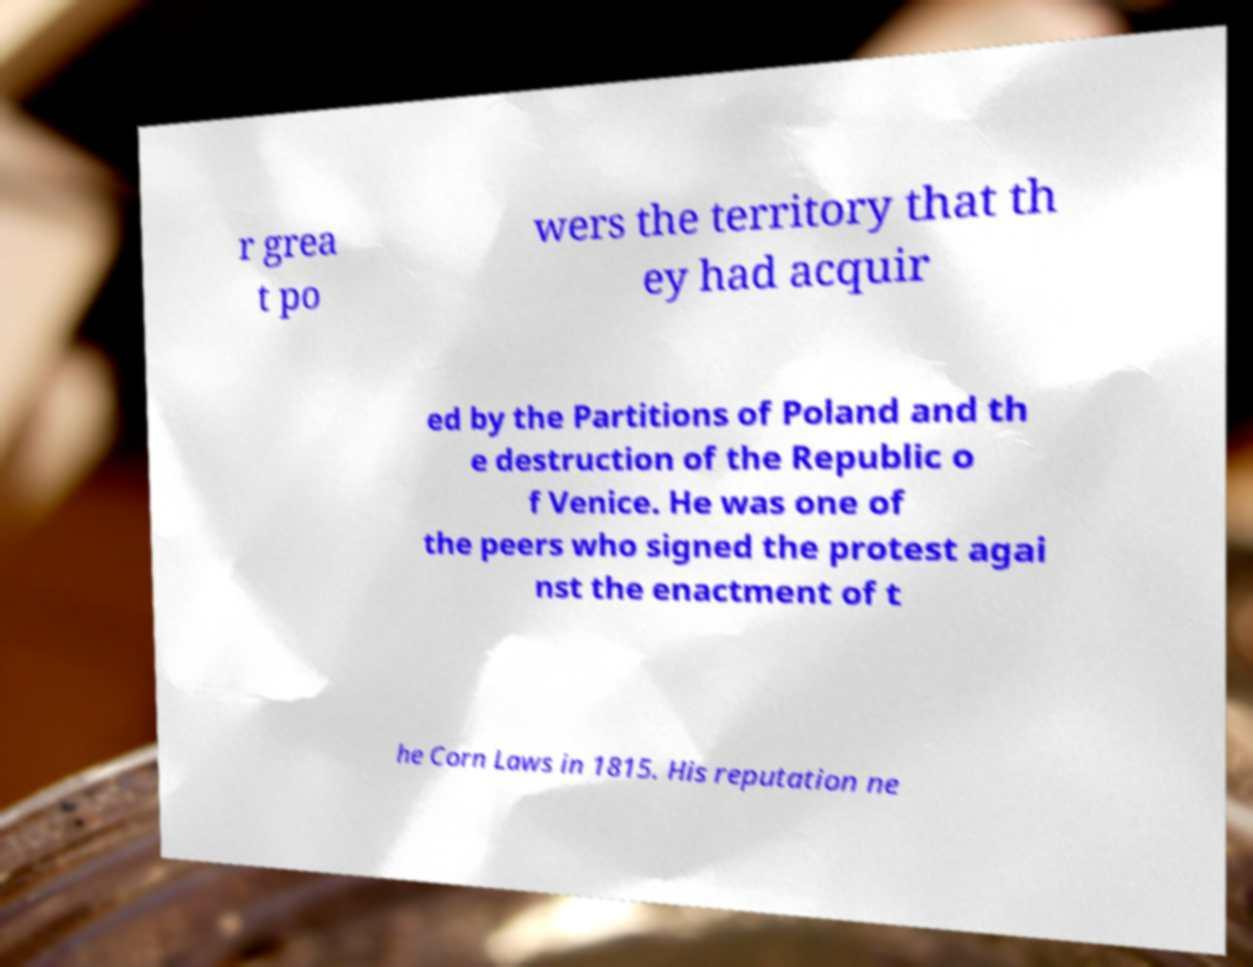For documentation purposes, I need the text within this image transcribed. Could you provide that? r grea t po wers the territory that th ey had acquir ed by the Partitions of Poland and th e destruction of the Republic o f Venice. He was one of the peers who signed the protest agai nst the enactment of t he Corn Laws in 1815. His reputation ne 